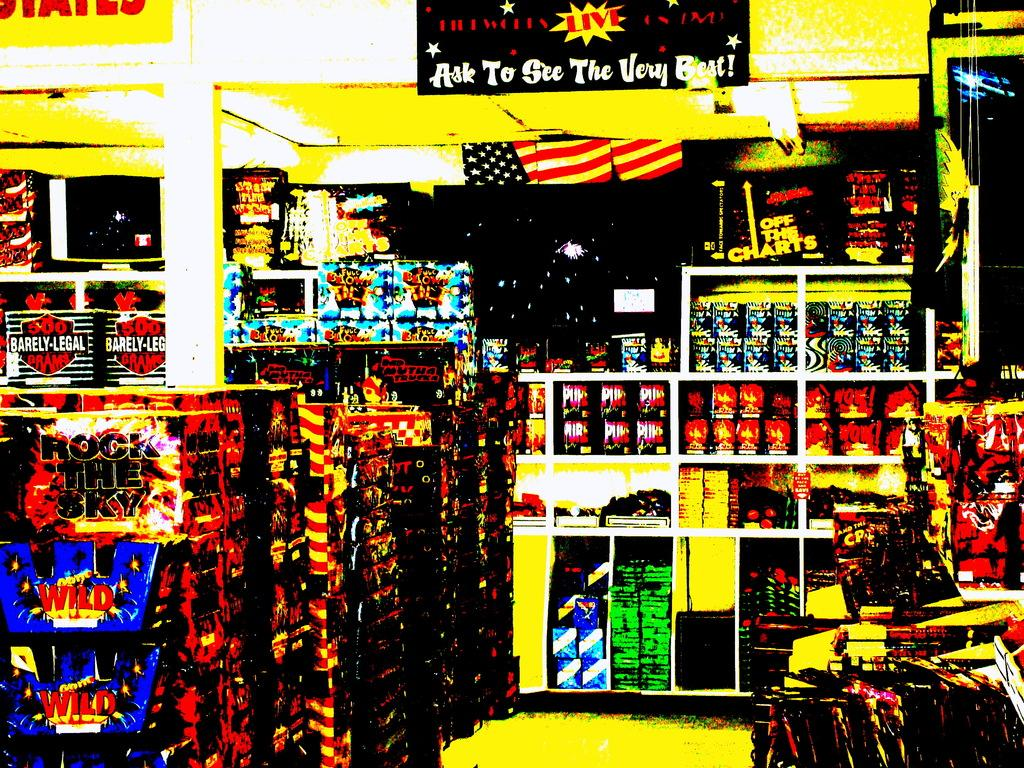<image>
Create a compact narrative representing the image presented. A painting of the inside of a fireworks store includes a sign stating "ask to see the very best!". 